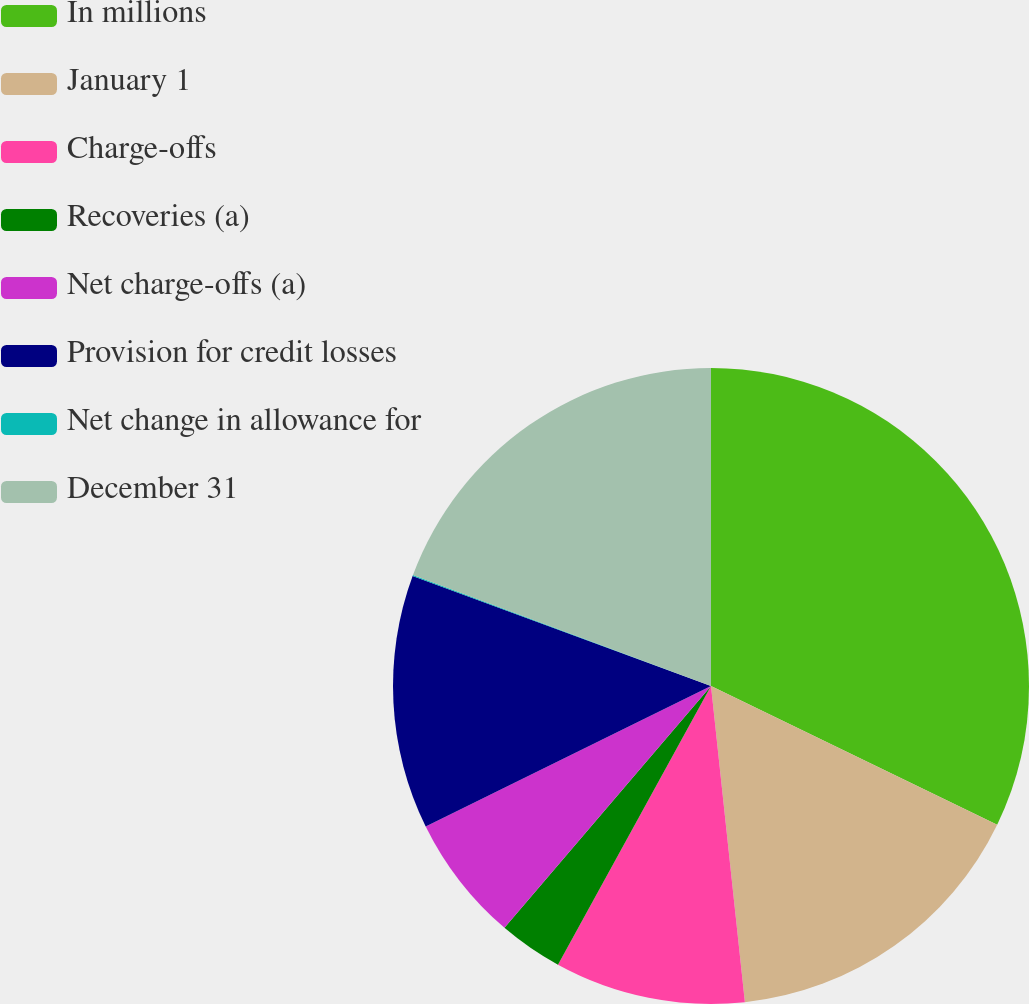Convert chart to OTSL. <chart><loc_0><loc_0><loc_500><loc_500><pie_chart><fcel>In millions<fcel>January 1<fcel>Charge-offs<fcel>Recoveries (a)<fcel>Net charge-offs (a)<fcel>Provision for credit losses<fcel>Net change in allowance for<fcel>December 31<nl><fcel>32.18%<fcel>16.12%<fcel>9.69%<fcel>3.26%<fcel>6.47%<fcel>12.9%<fcel>0.05%<fcel>19.33%<nl></chart> 